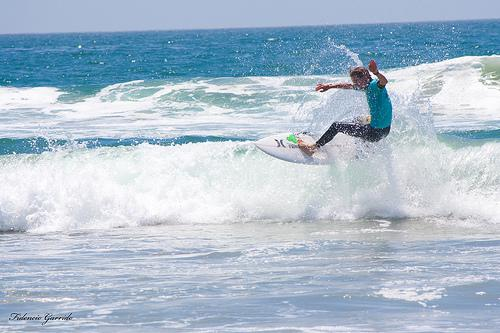Question: what color is the surfer's shirt?
Choices:
A. His shirt is blue.
B. His shirt is green.
C. His shirt is black.
D. His shirt is yellow.
Answer with the letter. Answer: A Question: what is the man doing?
Choices:
A. Swimming.
B. The man is surfing.
C. Laying on beach.
D. Sailing.
Answer with the letter. Answer: B Question: where did this picture take place?
Choices:
A. At the beach.
B. At the park.
C. At a party.
D. It took place on the water.
Answer with the letter. Answer: D Question: how does the day look?
Choices:
A. The day looks nice and cool.
B. The day looks warm and humid.
C. The day looks calm and cool.
D. The day looks warm and calm.
Answer with the letter. Answer: A Question: who is in the picture?
Choices:
A. A surfer is in the picture.
B. A wave is in the picture.
C. A dolphin is in the picture.
D. A beach is in the picture.
Answer with the letter. Answer: A 